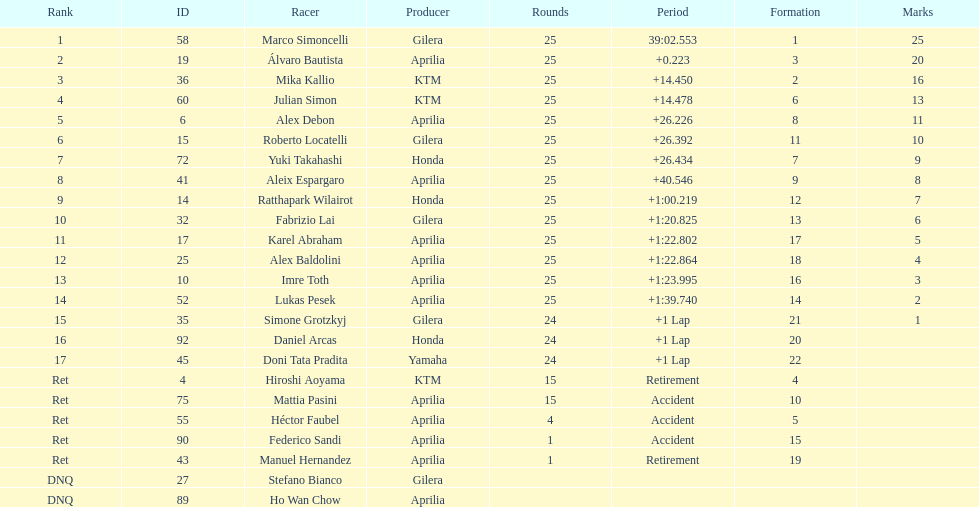What is the total number of laps performed by rider imre toth? 25. 